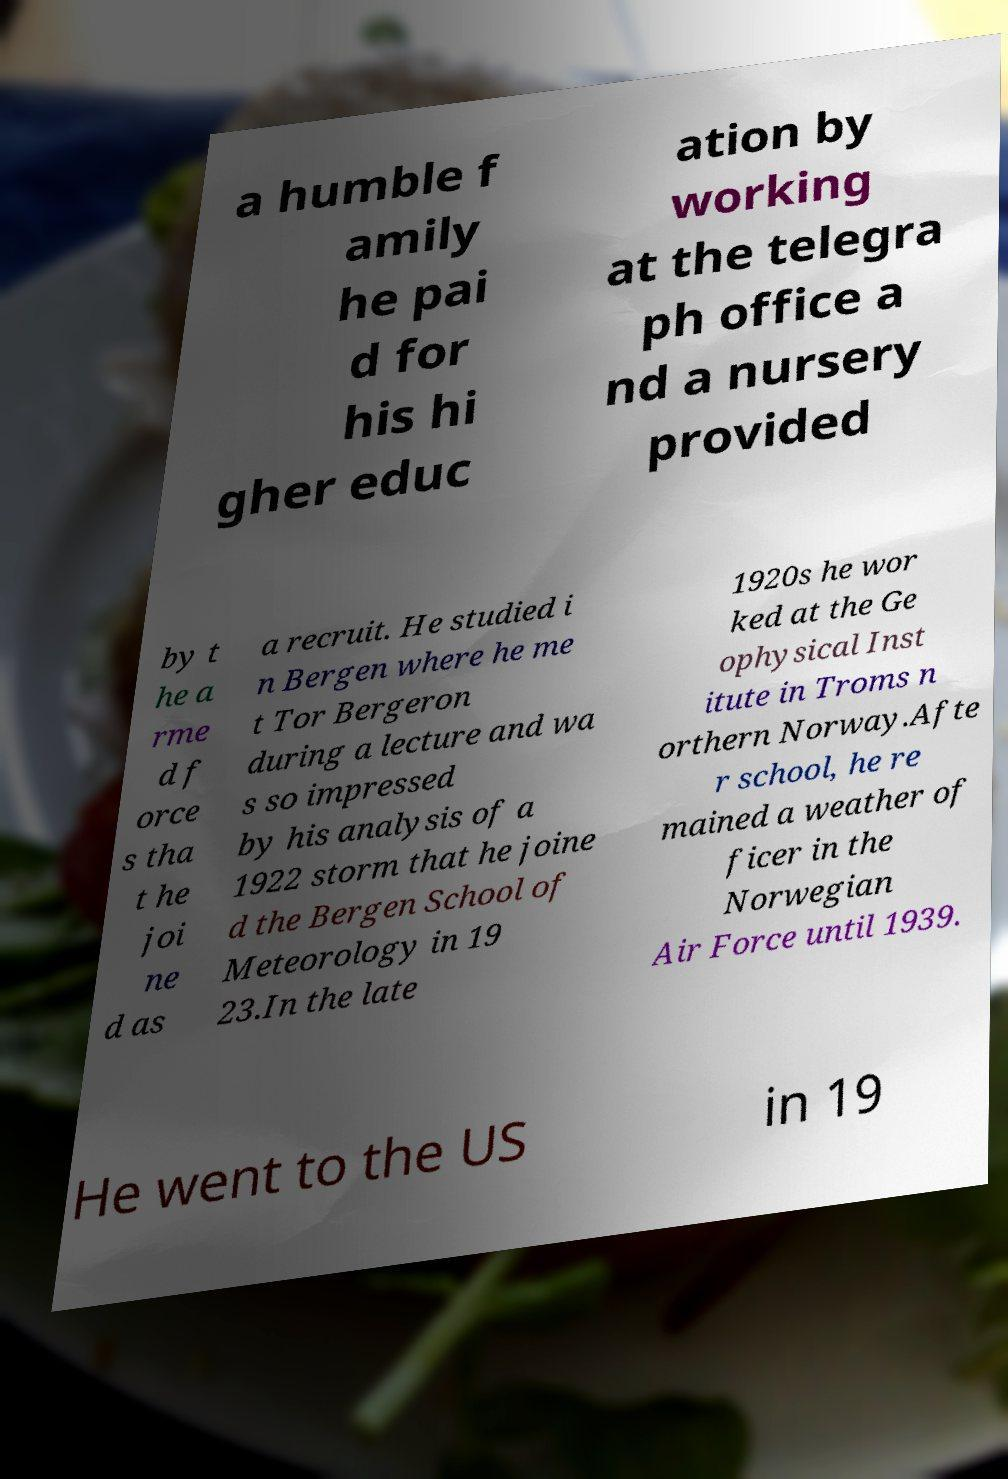Can you read and provide the text displayed in the image?This photo seems to have some interesting text. Can you extract and type it out for me? a humble f amily he pai d for his hi gher educ ation by working at the telegra ph office a nd a nursery provided by t he a rme d f orce s tha t he joi ne d as a recruit. He studied i n Bergen where he me t Tor Bergeron during a lecture and wa s so impressed by his analysis of a 1922 storm that he joine d the Bergen School of Meteorology in 19 23.In the late 1920s he wor ked at the Ge ophysical Inst itute in Troms n orthern Norway.Afte r school, he re mained a weather of ficer in the Norwegian Air Force until 1939. He went to the US in 19 